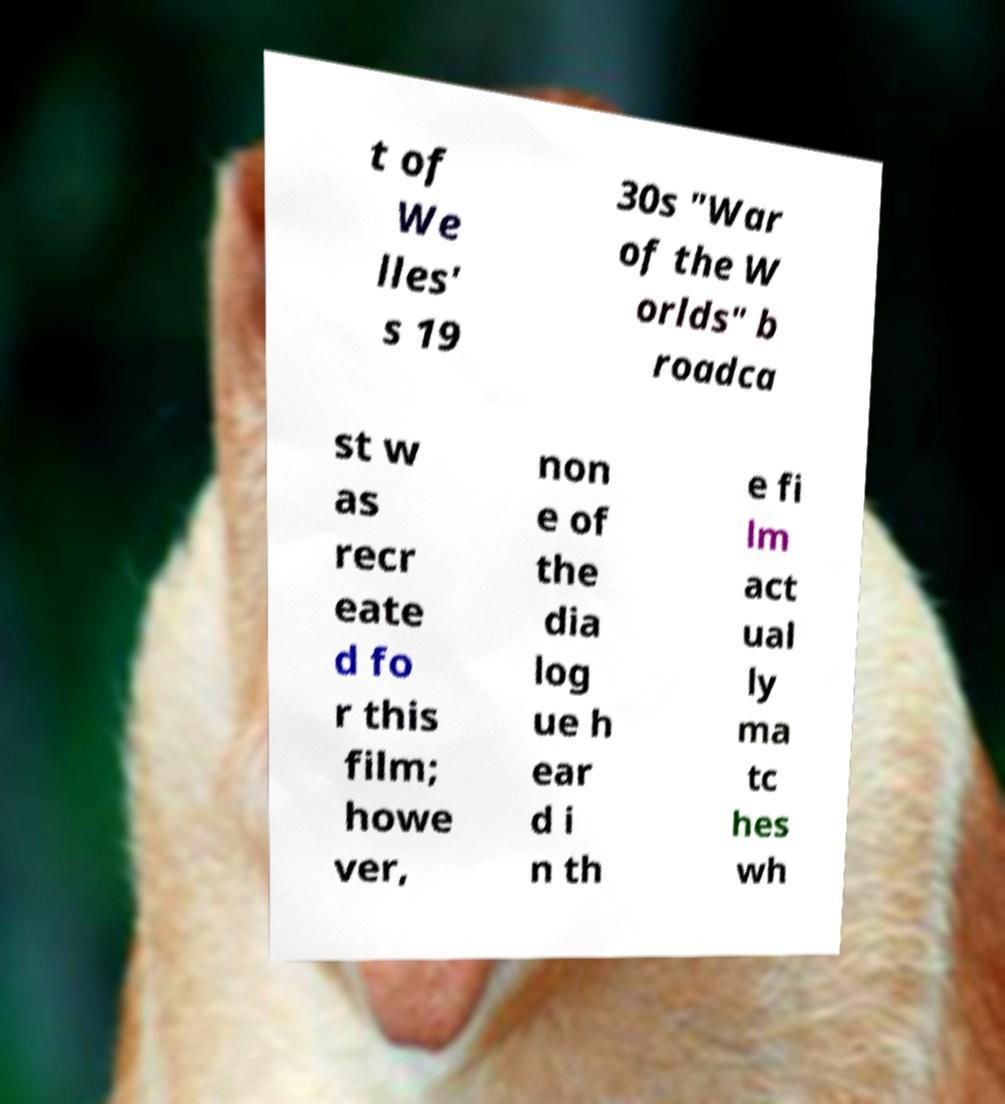There's text embedded in this image that I need extracted. Can you transcribe it verbatim? t of We lles' s 19 30s "War of the W orlds" b roadca st w as recr eate d fo r this film; howe ver, non e of the dia log ue h ear d i n th e fi lm act ual ly ma tc hes wh 